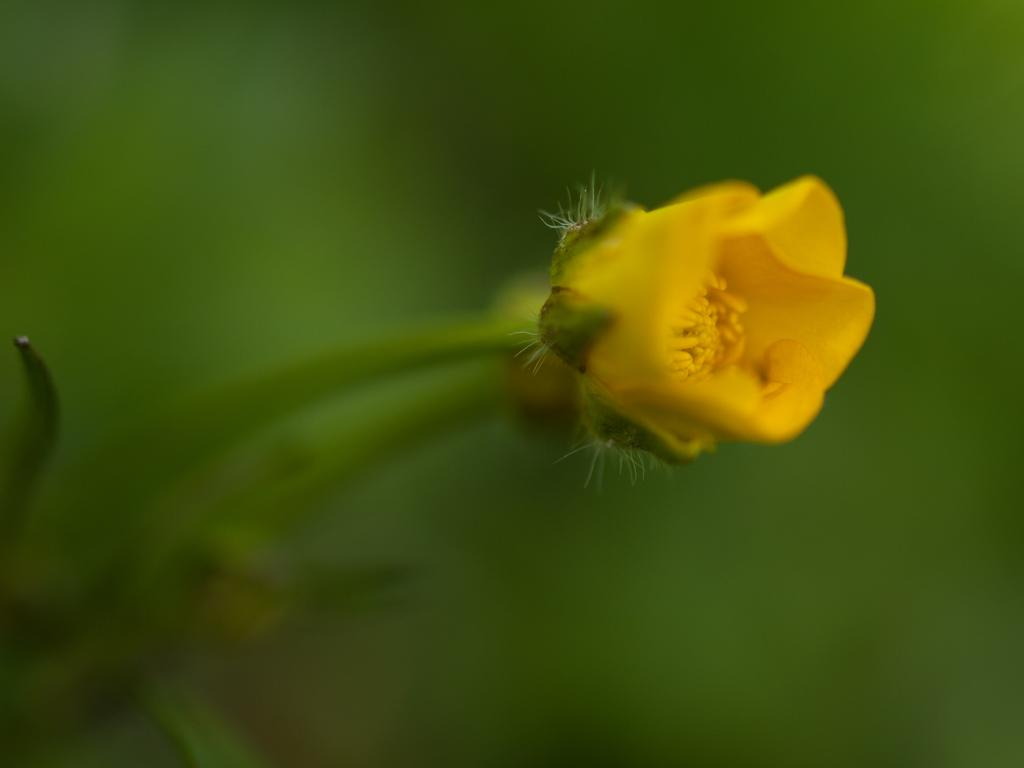What type of flower is in the image? There is a yellow flower in the image. Where is the flower located? The flower is on a plant. Can you describe the background of the image? The background of the image is blurry. What is the flower's tendency to grip objects in the image? Flowers do not have the ability to grip objects, so this question cannot be answered. 